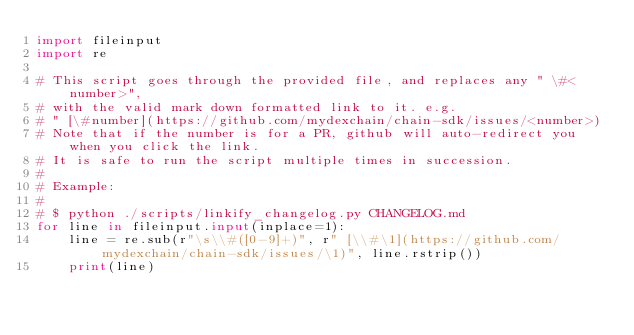Convert code to text. <code><loc_0><loc_0><loc_500><loc_500><_Python_>import fileinput
import re

# This script goes through the provided file, and replaces any " \#<number>",
# with the valid mark down formatted link to it. e.g.
# " [\#number](https://github.com/mydexchain/chain-sdk/issues/<number>)
# Note that if the number is for a PR, github will auto-redirect you when you click the link.
# It is safe to run the script multiple times in succession. 
#
# Example:
#
# $ python ./scripts/linkify_changelog.py CHANGELOG.md
for line in fileinput.input(inplace=1):
    line = re.sub(r"\s\\#([0-9]+)", r" [\\#\1](https://github.com/mydexchain/chain-sdk/issues/\1)", line.rstrip())
    print(line)</code> 